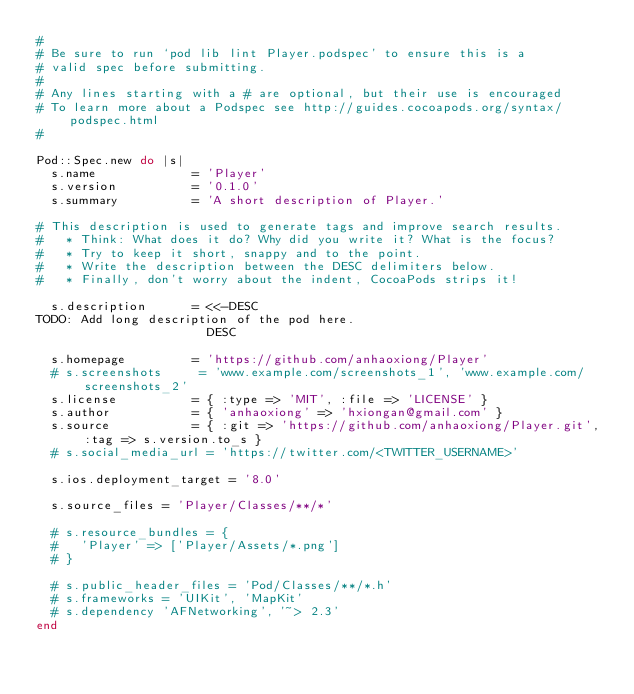<code> <loc_0><loc_0><loc_500><loc_500><_Ruby_>#
# Be sure to run `pod lib lint Player.podspec' to ensure this is a
# valid spec before submitting.
#
# Any lines starting with a # are optional, but their use is encouraged
# To learn more about a Podspec see http://guides.cocoapods.org/syntax/podspec.html
#

Pod::Spec.new do |s|
  s.name             = 'Player'
  s.version          = '0.1.0'
  s.summary          = 'A short description of Player.'

# This description is used to generate tags and improve search results.
#   * Think: What does it do? Why did you write it? What is the focus?
#   * Try to keep it short, snappy and to the point.
#   * Write the description between the DESC delimiters below.
#   * Finally, don't worry about the indent, CocoaPods strips it!

  s.description      = <<-DESC
TODO: Add long description of the pod here.
                       DESC

  s.homepage         = 'https://github.com/anhaoxiong/Player'
  # s.screenshots     = 'www.example.com/screenshots_1', 'www.example.com/screenshots_2'
  s.license          = { :type => 'MIT', :file => 'LICENSE' }
  s.author           = { 'anhaoxiong' => 'hxiongan@gmail.com' }
  s.source           = { :git => 'https://github.com/anhaoxiong/Player.git', :tag => s.version.to_s }
  # s.social_media_url = 'https://twitter.com/<TWITTER_USERNAME>'

  s.ios.deployment_target = '8.0'

  s.source_files = 'Player/Classes/**/*'
  
  # s.resource_bundles = {
  #   'Player' => ['Player/Assets/*.png']
  # }

  # s.public_header_files = 'Pod/Classes/**/*.h'
  # s.frameworks = 'UIKit', 'MapKit'
  # s.dependency 'AFNetworking', '~> 2.3'
end
</code> 